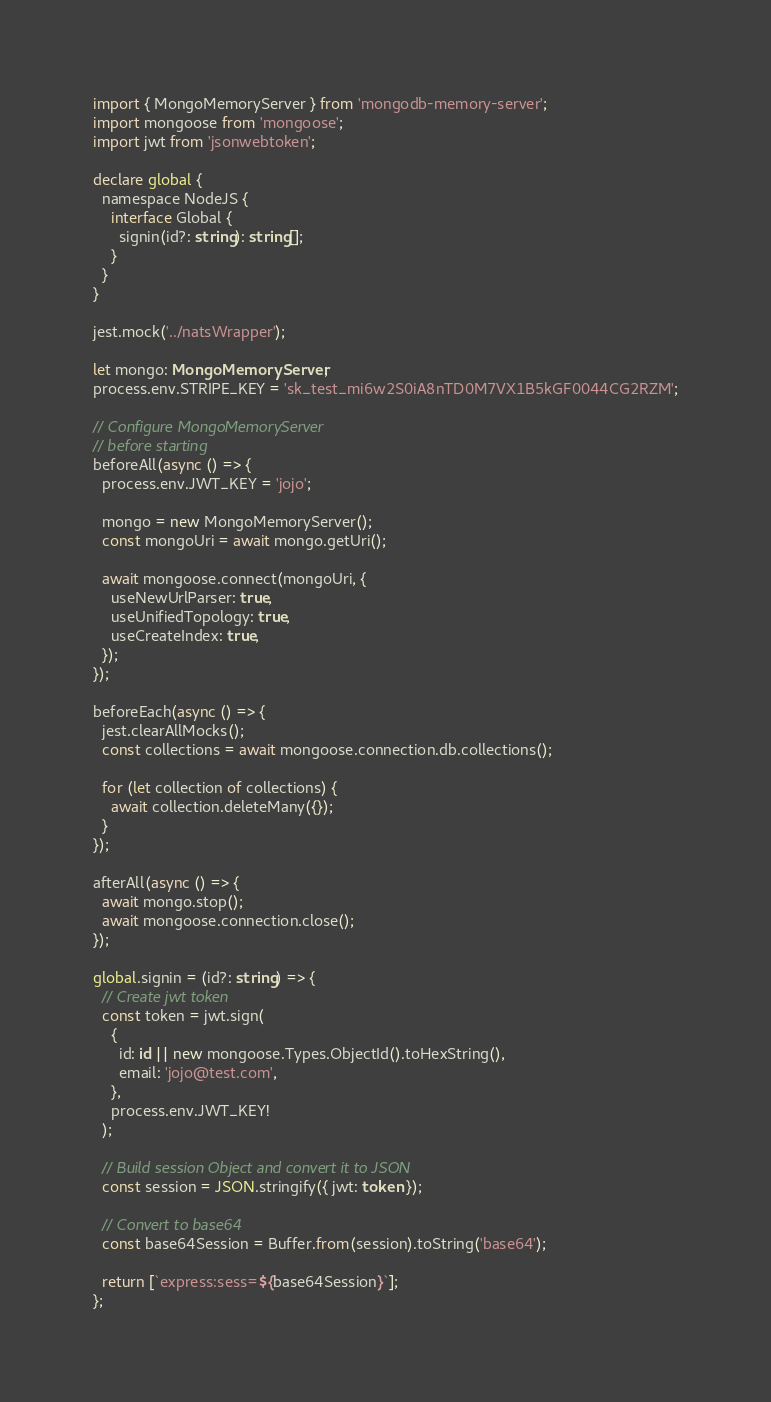<code> <loc_0><loc_0><loc_500><loc_500><_TypeScript_>import { MongoMemoryServer } from 'mongodb-memory-server';
import mongoose from 'mongoose';
import jwt from 'jsonwebtoken';

declare global {
  namespace NodeJS {
    interface Global {
      signin(id?: string): string[];
    }
  }
}

jest.mock('../natsWrapper');

let mongo: MongoMemoryServer;
process.env.STRIPE_KEY = 'sk_test_mi6w2S0iA8nTD0M7VX1B5kGF0044CG2RZM';

// Configure MongoMemoryServer
// before starting
beforeAll(async () => {
  process.env.JWT_KEY = 'jojo';

  mongo = new MongoMemoryServer();
  const mongoUri = await mongo.getUri();

  await mongoose.connect(mongoUri, {
    useNewUrlParser: true,
    useUnifiedTopology: true,
    useCreateIndex: true,
  });
});

beforeEach(async () => {
  jest.clearAllMocks();
  const collections = await mongoose.connection.db.collections();

  for (let collection of collections) {
    await collection.deleteMany({});
  }
});

afterAll(async () => {
  await mongo.stop();
  await mongoose.connection.close();
});

global.signin = (id?: string) => {
  // Create jwt token
  const token = jwt.sign(
    {
      id: id || new mongoose.Types.ObjectId().toHexString(),
      email: 'jojo@test.com',
    },
    process.env.JWT_KEY!
  );

  // Build session Object and convert it to JSON
  const session = JSON.stringify({ jwt: token });

  // Convert to base64
  const base64Session = Buffer.from(session).toString('base64');

  return [`express:sess=${base64Session}`];
};
</code> 